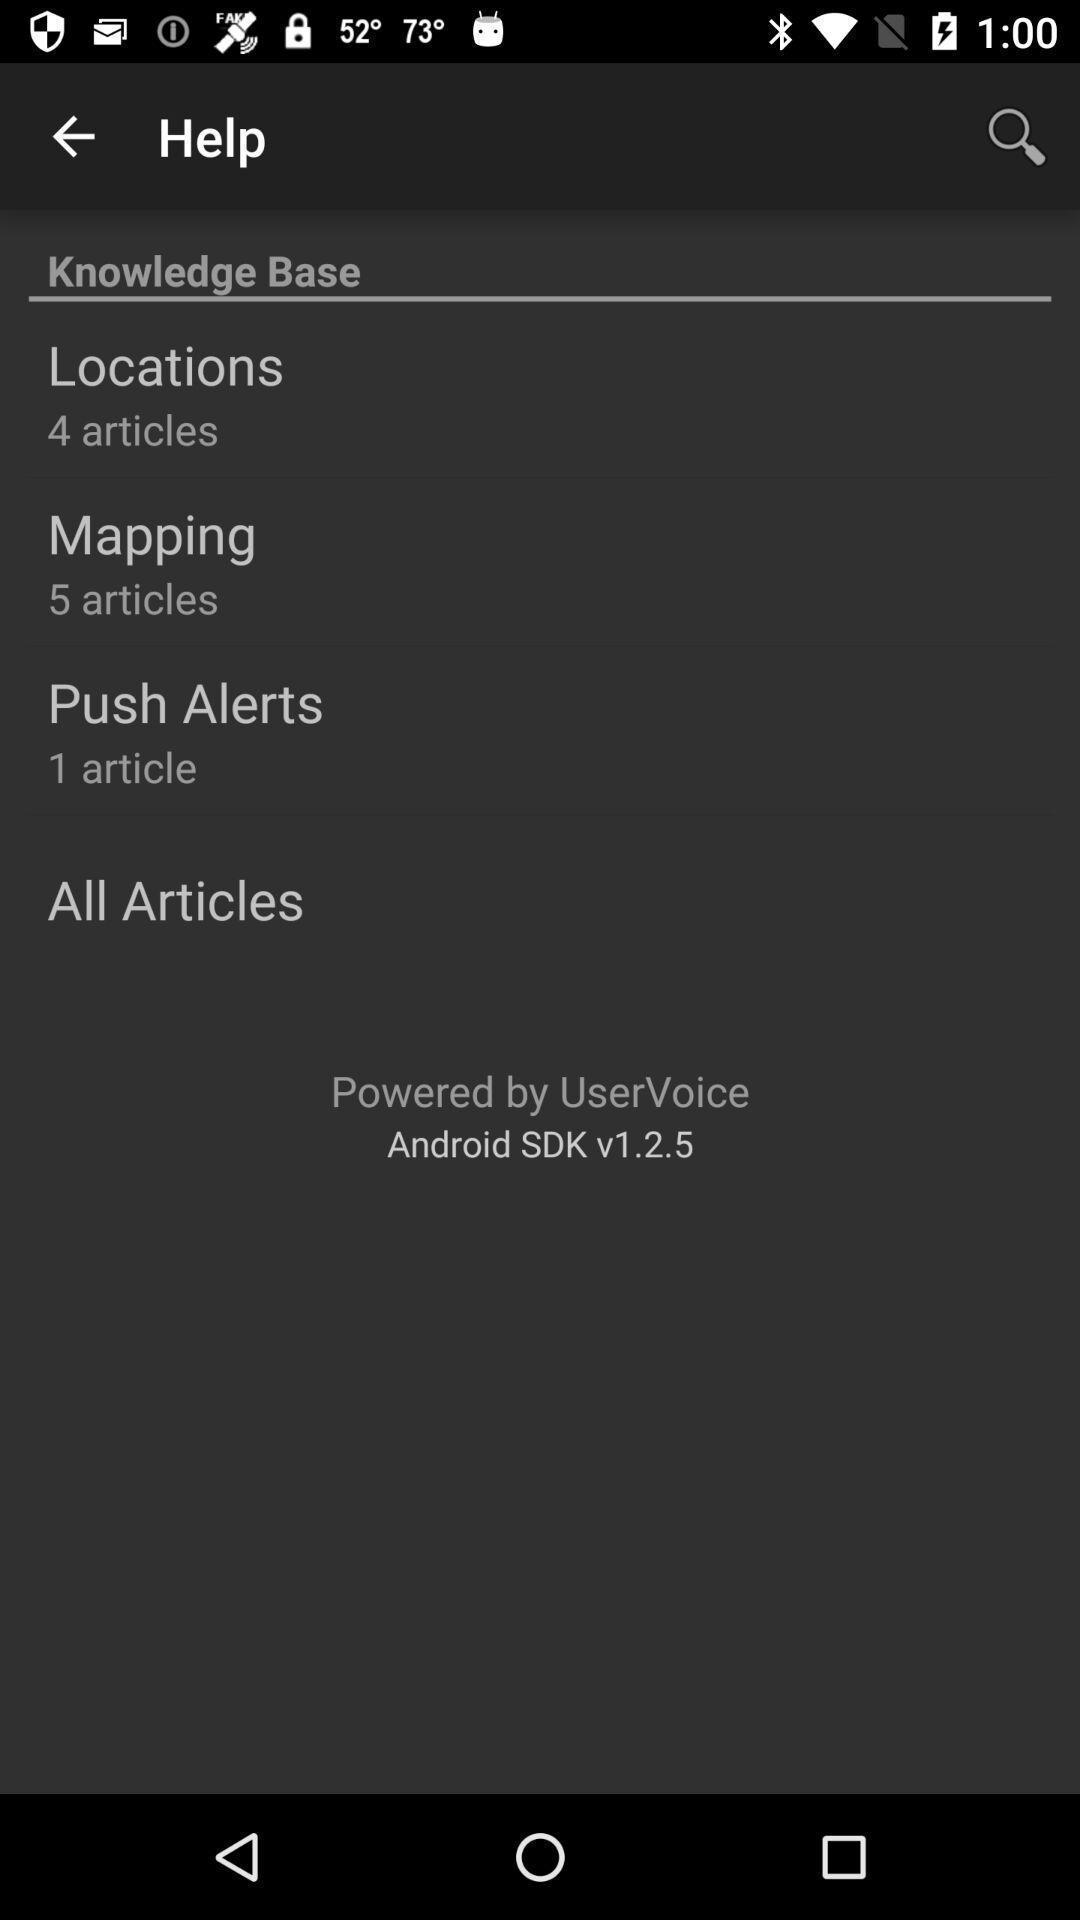Please provide a description for this image. Pop-up showing menu in help option with search bar. 